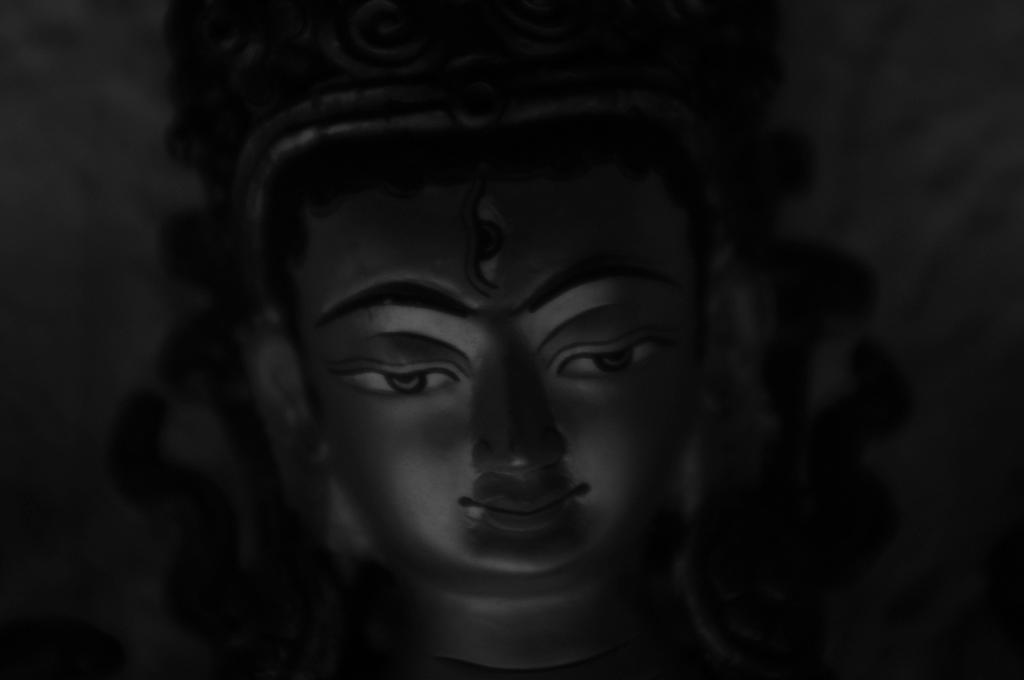Please provide a concise description of this image. This is a black and white image. In the middle of this image there is an idol. The background is in black color. 